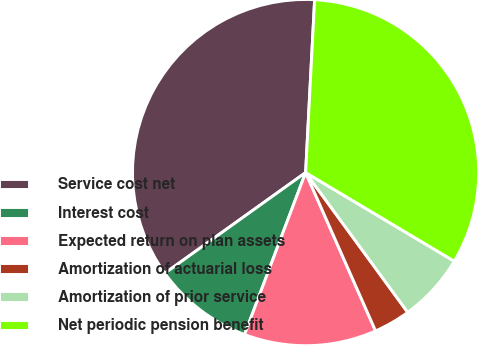Convert chart. <chart><loc_0><loc_0><loc_500><loc_500><pie_chart><fcel>Service cost net<fcel>Interest cost<fcel>Expected return on plan assets<fcel>Amortization of actuarial loss<fcel>Amortization of prior service<fcel>Net periodic pension benefit<nl><fcel>35.71%<fcel>9.38%<fcel>12.36%<fcel>3.42%<fcel>6.4%<fcel>32.73%<nl></chart> 